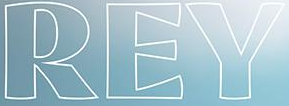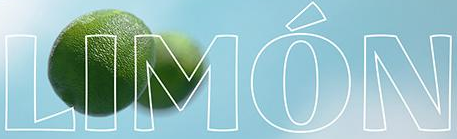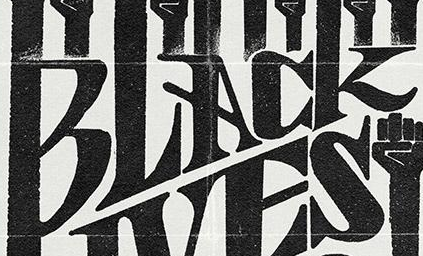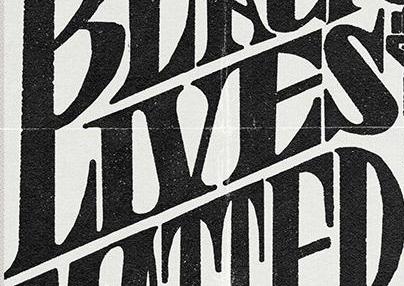Read the text content from these images in order, separated by a semicolon. REY; LIMÓN; BLACK; LIVES 